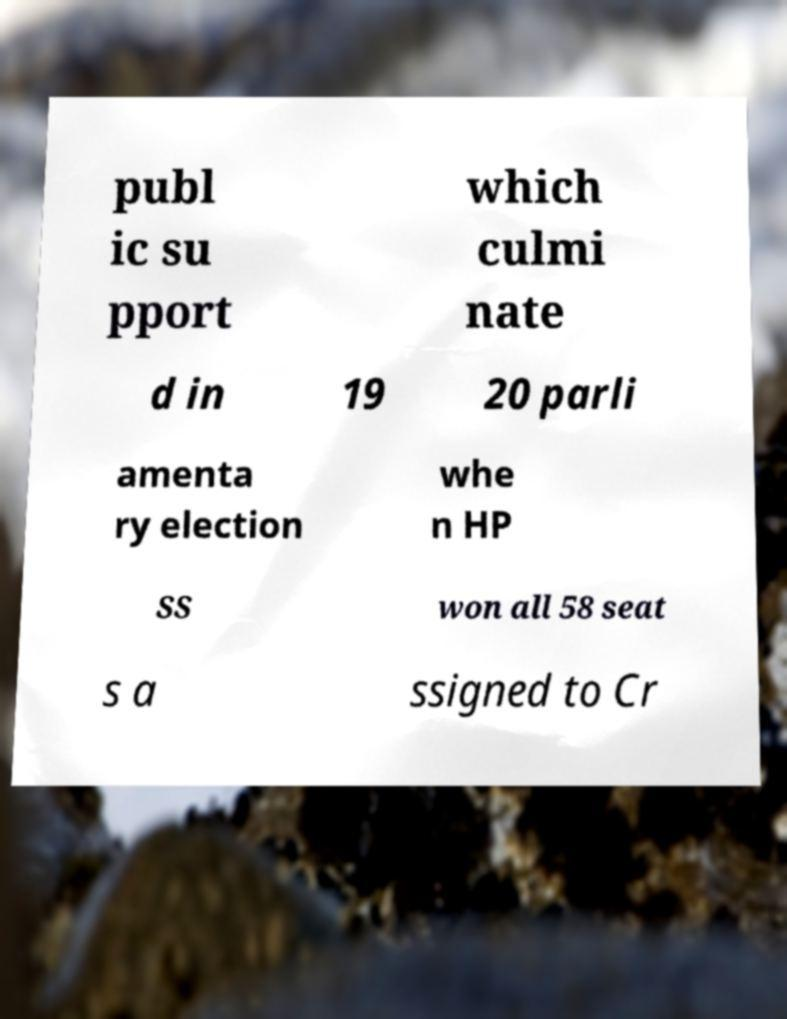I need the written content from this picture converted into text. Can you do that? publ ic su pport which culmi nate d in 19 20 parli amenta ry election whe n HP SS won all 58 seat s a ssigned to Cr 